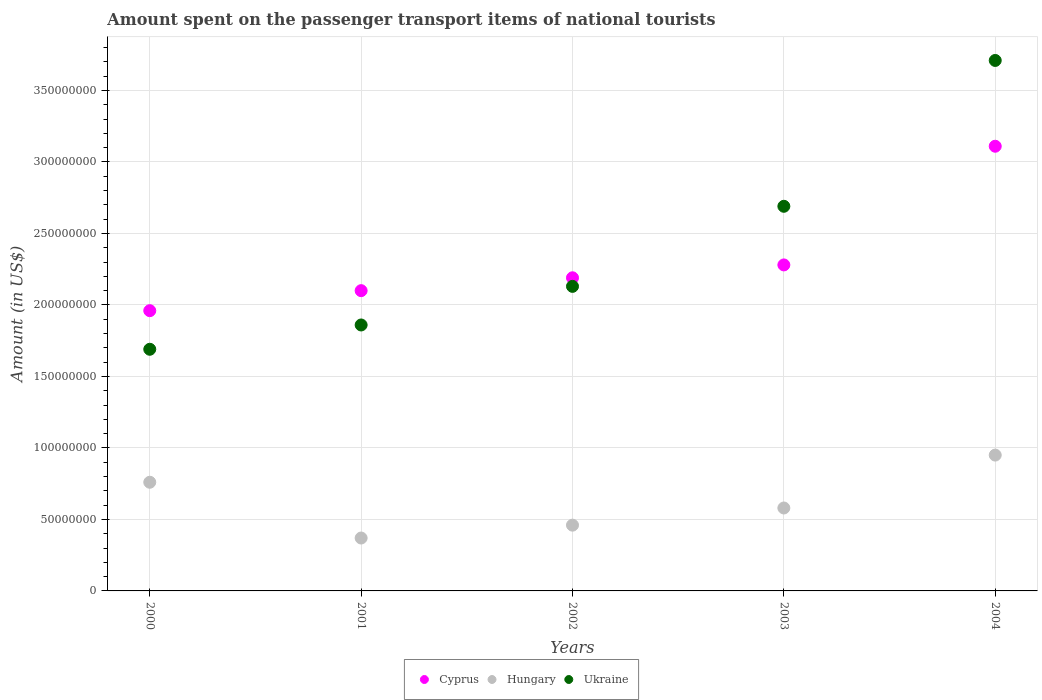How many different coloured dotlines are there?
Provide a succinct answer. 3. What is the amount spent on the passenger transport items of national tourists in Ukraine in 2001?
Your response must be concise. 1.86e+08. Across all years, what is the maximum amount spent on the passenger transport items of national tourists in Cyprus?
Make the answer very short. 3.11e+08. Across all years, what is the minimum amount spent on the passenger transport items of national tourists in Ukraine?
Your answer should be compact. 1.69e+08. What is the total amount spent on the passenger transport items of national tourists in Ukraine in the graph?
Give a very brief answer. 1.21e+09. What is the difference between the amount spent on the passenger transport items of national tourists in Ukraine in 2001 and that in 2004?
Provide a succinct answer. -1.85e+08. What is the difference between the amount spent on the passenger transport items of national tourists in Cyprus in 2002 and the amount spent on the passenger transport items of national tourists in Ukraine in 2000?
Provide a short and direct response. 5.00e+07. What is the average amount spent on the passenger transport items of national tourists in Hungary per year?
Provide a short and direct response. 6.24e+07. In the year 2002, what is the difference between the amount spent on the passenger transport items of national tourists in Hungary and amount spent on the passenger transport items of national tourists in Ukraine?
Offer a very short reply. -1.67e+08. In how many years, is the amount spent on the passenger transport items of national tourists in Ukraine greater than 270000000 US$?
Your response must be concise. 1. What is the ratio of the amount spent on the passenger transport items of national tourists in Ukraine in 2002 to that in 2003?
Keep it short and to the point. 0.79. Is the amount spent on the passenger transport items of national tourists in Cyprus in 2001 less than that in 2004?
Offer a terse response. Yes. Is the difference between the amount spent on the passenger transport items of national tourists in Hungary in 2000 and 2003 greater than the difference between the amount spent on the passenger transport items of national tourists in Ukraine in 2000 and 2003?
Make the answer very short. Yes. What is the difference between the highest and the second highest amount spent on the passenger transport items of national tourists in Hungary?
Provide a succinct answer. 1.90e+07. What is the difference between the highest and the lowest amount spent on the passenger transport items of national tourists in Ukraine?
Make the answer very short. 2.02e+08. In how many years, is the amount spent on the passenger transport items of national tourists in Cyprus greater than the average amount spent on the passenger transport items of national tourists in Cyprus taken over all years?
Make the answer very short. 1. Does the amount spent on the passenger transport items of national tourists in Ukraine monotonically increase over the years?
Ensure brevity in your answer.  Yes. Is the amount spent on the passenger transport items of national tourists in Ukraine strictly greater than the amount spent on the passenger transport items of national tourists in Cyprus over the years?
Ensure brevity in your answer.  No. Is the amount spent on the passenger transport items of national tourists in Hungary strictly less than the amount spent on the passenger transport items of national tourists in Cyprus over the years?
Your response must be concise. Yes. Are the values on the major ticks of Y-axis written in scientific E-notation?
Offer a terse response. No. Where does the legend appear in the graph?
Give a very brief answer. Bottom center. What is the title of the graph?
Give a very brief answer. Amount spent on the passenger transport items of national tourists. What is the label or title of the X-axis?
Keep it short and to the point. Years. What is the Amount (in US$) in Cyprus in 2000?
Give a very brief answer. 1.96e+08. What is the Amount (in US$) of Hungary in 2000?
Your answer should be very brief. 7.60e+07. What is the Amount (in US$) in Ukraine in 2000?
Your answer should be compact. 1.69e+08. What is the Amount (in US$) of Cyprus in 2001?
Your response must be concise. 2.10e+08. What is the Amount (in US$) of Hungary in 2001?
Make the answer very short. 3.70e+07. What is the Amount (in US$) of Ukraine in 2001?
Make the answer very short. 1.86e+08. What is the Amount (in US$) of Cyprus in 2002?
Offer a very short reply. 2.19e+08. What is the Amount (in US$) of Hungary in 2002?
Ensure brevity in your answer.  4.60e+07. What is the Amount (in US$) of Ukraine in 2002?
Offer a terse response. 2.13e+08. What is the Amount (in US$) in Cyprus in 2003?
Keep it short and to the point. 2.28e+08. What is the Amount (in US$) of Hungary in 2003?
Give a very brief answer. 5.80e+07. What is the Amount (in US$) of Ukraine in 2003?
Make the answer very short. 2.69e+08. What is the Amount (in US$) of Cyprus in 2004?
Your response must be concise. 3.11e+08. What is the Amount (in US$) of Hungary in 2004?
Offer a very short reply. 9.50e+07. What is the Amount (in US$) of Ukraine in 2004?
Your answer should be very brief. 3.71e+08. Across all years, what is the maximum Amount (in US$) of Cyprus?
Offer a very short reply. 3.11e+08. Across all years, what is the maximum Amount (in US$) of Hungary?
Keep it short and to the point. 9.50e+07. Across all years, what is the maximum Amount (in US$) of Ukraine?
Give a very brief answer. 3.71e+08. Across all years, what is the minimum Amount (in US$) in Cyprus?
Provide a succinct answer. 1.96e+08. Across all years, what is the minimum Amount (in US$) in Hungary?
Offer a terse response. 3.70e+07. Across all years, what is the minimum Amount (in US$) of Ukraine?
Keep it short and to the point. 1.69e+08. What is the total Amount (in US$) in Cyprus in the graph?
Your answer should be compact. 1.16e+09. What is the total Amount (in US$) in Hungary in the graph?
Provide a succinct answer. 3.12e+08. What is the total Amount (in US$) of Ukraine in the graph?
Ensure brevity in your answer.  1.21e+09. What is the difference between the Amount (in US$) in Cyprus in 2000 and that in 2001?
Keep it short and to the point. -1.40e+07. What is the difference between the Amount (in US$) in Hungary in 2000 and that in 2001?
Make the answer very short. 3.90e+07. What is the difference between the Amount (in US$) of Ukraine in 2000 and that in 2001?
Your response must be concise. -1.70e+07. What is the difference between the Amount (in US$) in Cyprus in 2000 and that in 2002?
Provide a succinct answer. -2.30e+07. What is the difference between the Amount (in US$) in Hungary in 2000 and that in 2002?
Your response must be concise. 3.00e+07. What is the difference between the Amount (in US$) of Ukraine in 2000 and that in 2002?
Give a very brief answer. -4.40e+07. What is the difference between the Amount (in US$) of Cyprus in 2000 and that in 2003?
Your answer should be very brief. -3.20e+07. What is the difference between the Amount (in US$) of Hungary in 2000 and that in 2003?
Make the answer very short. 1.80e+07. What is the difference between the Amount (in US$) in Ukraine in 2000 and that in 2003?
Give a very brief answer. -1.00e+08. What is the difference between the Amount (in US$) in Cyprus in 2000 and that in 2004?
Your answer should be compact. -1.15e+08. What is the difference between the Amount (in US$) in Hungary in 2000 and that in 2004?
Offer a terse response. -1.90e+07. What is the difference between the Amount (in US$) in Ukraine in 2000 and that in 2004?
Make the answer very short. -2.02e+08. What is the difference between the Amount (in US$) of Cyprus in 2001 and that in 2002?
Offer a terse response. -9.00e+06. What is the difference between the Amount (in US$) in Hungary in 2001 and that in 2002?
Offer a very short reply. -9.00e+06. What is the difference between the Amount (in US$) of Ukraine in 2001 and that in 2002?
Your response must be concise. -2.70e+07. What is the difference between the Amount (in US$) of Cyprus in 2001 and that in 2003?
Provide a succinct answer. -1.80e+07. What is the difference between the Amount (in US$) of Hungary in 2001 and that in 2003?
Make the answer very short. -2.10e+07. What is the difference between the Amount (in US$) of Ukraine in 2001 and that in 2003?
Your answer should be compact. -8.30e+07. What is the difference between the Amount (in US$) in Cyprus in 2001 and that in 2004?
Your answer should be compact. -1.01e+08. What is the difference between the Amount (in US$) of Hungary in 2001 and that in 2004?
Give a very brief answer. -5.80e+07. What is the difference between the Amount (in US$) in Ukraine in 2001 and that in 2004?
Provide a short and direct response. -1.85e+08. What is the difference between the Amount (in US$) in Cyprus in 2002 and that in 2003?
Make the answer very short. -9.00e+06. What is the difference between the Amount (in US$) of Hungary in 2002 and that in 2003?
Provide a succinct answer. -1.20e+07. What is the difference between the Amount (in US$) of Ukraine in 2002 and that in 2003?
Your answer should be compact. -5.60e+07. What is the difference between the Amount (in US$) of Cyprus in 2002 and that in 2004?
Your answer should be compact. -9.20e+07. What is the difference between the Amount (in US$) in Hungary in 2002 and that in 2004?
Provide a succinct answer. -4.90e+07. What is the difference between the Amount (in US$) in Ukraine in 2002 and that in 2004?
Your answer should be very brief. -1.58e+08. What is the difference between the Amount (in US$) of Cyprus in 2003 and that in 2004?
Your answer should be compact. -8.30e+07. What is the difference between the Amount (in US$) of Hungary in 2003 and that in 2004?
Offer a terse response. -3.70e+07. What is the difference between the Amount (in US$) in Ukraine in 2003 and that in 2004?
Your answer should be compact. -1.02e+08. What is the difference between the Amount (in US$) in Cyprus in 2000 and the Amount (in US$) in Hungary in 2001?
Your response must be concise. 1.59e+08. What is the difference between the Amount (in US$) of Hungary in 2000 and the Amount (in US$) of Ukraine in 2001?
Make the answer very short. -1.10e+08. What is the difference between the Amount (in US$) in Cyprus in 2000 and the Amount (in US$) in Hungary in 2002?
Your answer should be very brief. 1.50e+08. What is the difference between the Amount (in US$) of Cyprus in 2000 and the Amount (in US$) of Ukraine in 2002?
Make the answer very short. -1.70e+07. What is the difference between the Amount (in US$) in Hungary in 2000 and the Amount (in US$) in Ukraine in 2002?
Offer a very short reply. -1.37e+08. What is the difference between the Amount (in US$) of Cyprus in 2000 and the Amount (in US$) of Hungary in 2003?
Keep it short and to the point. 1.38e+08. What is the difference between the Amount (in US$) in Cyprus in 2000 and the Amount (in US$) in Ukraine in 2003?
Give a very brief answer. -7.30e+07. What is the difference between the Amount (in US$) of Hungary in 2000 and the Amount (in US$) of Ukraine in 2003?
Give a very brief answer. -1.93e+08. What is the difference between the Amount (in US$) in Cyprus in 2000 and the Amount (in US$) in Hungary in 2004?
Ensure brevity in your answer.  1.01e+08. What is the difference between the Amount (in US$) in Cyprus in 2000 and the Amount (in US$) in Ukraine in 2004?
Make the answer very short. -1.75e+08. What is the difference between the Amount (in US$) in Hungary in 2000 and the Amount (in US$) in Ukraine in 2004?
Provide a short and direct response. -2.95e+08. What is the difference between the Amount (in US$) of Cyprus in 2001 and the Amount (in US$) of Hungary in 2002?
Offer a very short reply. 1.64e+08. What is the difference between the Amount (in US$) in Cyprus in 2001 and the Amount (in US$) in Ukraine in 2002?
Provide a succinct answer. -3.00e+06. What is the difference between the Amount (in US$) of Hungary in 2001 and the Amount (in US$) of Ukraine in 2002?
Your answer should be very brief. -1.76e+08. What is the difference between the Amount (in US$) of Cyprus in 2001 and the Amount (in US$) of Hungary in 2003?
Ensure brevity in your answer.  1.52e+08. What is the difference between the Amount (in US$) of Cyprus in 2001 and the Amount (in US$) of Ukraine in 2003?
Provide a short and direct response. -5.90e+07. What is the difference between the Amount (in US$) in Hungary in 2001 and the Amount (in US$) in Ukraine in 2003?
Offer a very short reply. -2.32e+08. What is the difference between the Amount (in US$) in Cyprus in 2001 and the Amount (in US$) in Hungary in 2004?
Your answer should be very brief. 1.15e+08. What is the difference between the Amount (in US$) in Cyprus in 2001 and the Amount (in US$) in Ukraine in 2004?
Keep it short and to the point. -1.61e+08. What is the difference between the Amount (in US$) in Hungary in 2001 and the Amount (in US$) in Ukraine in 2004?
Ensure brevity in your answer.  -3.34e+08. What is the difference between the Amount (in US$) of Cyprus in 2002 and the Amount (in US$) of Hungary in 2003?
Your answer should be very brief. 1.61e+08. What is the difference between the Amount (in US$) of Cyprus in 2002 and the Amount (in US$) of Ukraine in 2003?
Your response must be concise. -5.00e+07. What is the difference between the Amount (in US$) in Hungary in 2002 and the Amount (in US$) in Ukraine in 2003?
Provide a succinct answer. -2.23e+08. What is the difference between the Amount (in US$) in Cyprus in 2002 and the Amount (in US$) in Hungary in 2004?
Ensure brevity in your answer.  1.24e+08. What is the difference between the Amount (in US$) in Cyprus in 2002 and the Amount (in US$) in Ukraine in 2004?
Your answer should be very brief. -1.52e+08. What is the difference between the Amount (in US$) of Hungary in 2002 and the Amount (in US$) of Ukraine in 2004?
Your answer should be compact. -3.25e+08. What is the difference between the Amount (in US$) of Cyprus in 2003 and the Amount (in US$) of Hungary in 2004?
Provide a short and direct response. 1.33e+08. What is the difference between the Amount (in US$) of Cyprus in 2003 and the Amount (in US$) of Ukraine in 2004?
Provide a succinct answer. -1.43e+08. What is the difference between the Amount (in US$) in Hungary in 2003 and the Amount (in US$) in Ukraine in 2004?
Your response must be concise. -3.13e+08. What is the average Amount (in US$) in Cyprus per year?
Keep it short and to the point. 2.33e+08. What is the average Amount (in US$) of Hungary per year?
Keep it short and to the point. 6.24e+07. What is the average Amount (in US$) in Ukraine per year?
Provide a succinct answer. 2.42e+08. In the year 2000, what is the difference between the Amount (in US$) of Cyprus and Amount (in US$) of Hungary?
Your response must be concise. 1.20e+08. In the year 2000, what is the difference between the Amount (in US$) of Cyprus and Amount (in US$) of Ukraine?
Provide a succinct answer. 2.70e+07. In the year 2000, what is the difference between the Amount (in US$) in Hungary and Amount (in US$) in Ukraine?
Offer a terse response. -9.30e+07. In the year 2001, what is the difference between the Amount (in US$) of Cyprus and Amount (in US$) of Hungary?
Provide a succinct answer. 1.73e+08. In the year 2001, what is the difference between the Amount (in US$) of Cyprus and Amount (in US$) of Ukraine?
Ensure brevity in your answer.  2.40e+07. In the year 2001, what is the difference between the Amount (in US$) in Hungary and Amount (in US$) in Ukraine?
Your answer should be compact. -1.49e+08. In the year 2002, what is the difference between the Amount (in US$) in Cyprus and Amount (in US$) in Hungary?
Provide a succinct answer. 1.73e+08. In the year 2002, what is the difference between the Amount (in US$) of Hungary and Amount (in US$) of Ukraine?
Provide a short and direct response. -1.67e+08. In the year 2003, what is the difference between the Amount (in US$) of Cyprus and Amount (in US$) of Hungary?
Offer a terse response. 1.70e+08. In the year 2003, what is the difference between the Amount (in US$) of Cyprus and Amount (in US$) of Ukraine?
Offer a very short reply. -4.10e+07. In the year 2003, what is the difference between the Amount (in US$) in Hungary and Amount (in US$) in Ukraine?
Your answer should be very brief. -2.11e+08. In the year 2004, what is the difference between the Amount (in US$) in Cyprus and Amount (in US$) in Hungary?
Make the answer very short. 2.16e+08. In the year 2004, what is the difference between the Amount (in US$) in Cyprus and Amount (in US$) in Ukraine?
Offer a very short reply. -6.00e+07. In the year 2004, what is the difference between the Amount (in US$) of Hungary and Amount (in US$) of Ukraine?
Your answer should be compact. -2.76e+08. What is the ratio of the Amount (in US$) of Hungary in 2000 to that in 2001?
Offer a very short reply. 2.05. What is the ratio of the Amount (in US$) in Ukraine in 2000 to that in 2001?
Provide a short and direct response. 0.91. What is the ratio of the Amount (in US$) in Cyprus in 2000 to that in 2002?
Your answer should be compact. 0.9. What is the ratio of the Amount (in US$) of Hungary in 2000 to that in 2002?
Make the answer very short. 1.65. What is the ratio of the Amount (in US$) of Ukraine in 2000 to that in 2002?
Offer a terse response. 0.79. What is the ratio of the Amount (in US$) of Cyprus in 2000 to that in 2003?
Make the answer very short. 0.86. What is the ratio of the Amount (in US$) in Hungary in 2000 to that in 2003?
Provide a short and direct response. 1.31. What is the ratio of the Amount (in US$) in Ukraine in 2000 to that in 2003?
Offer a very short reply. 0.63. What is the ratio of the Amount (in US$) of Cyprus in 2000 to that in 2004?
Offer a very short reply. 0.63. What is the ratio of the Amount (in US$) in Ukraine in 2000 to that in 2004?
Keep it short and to the point. 0.46. What is the ratio of the Amount (in US$) of Cyprus in 2001 to that in 2002?
Ensure brevity in your answer.  0.96. What is the ratio of the Amount (in US$) of Hungary in 2001 to that in 2002?
Your answer should be compact. 0.8. What is the ratio of the Amount (in US$) of Ukraine in 2001 to that in 2002?
Offer a very short reply. 0.87. What is the ratio of the Amount (in US$) of Cyprus in 2001 to that in 2003?
Ensure brevity in your answer.  0.92. What is the ratio of the Amount (in US$) of Hungary in 2001 to that in 2003?
Provide a short and direct response. 0.64. What is the ratio of the Amount (in US$) in Ukraine in 2001 to that in 2003?
Offer a very short reply. 0.69. What is the ratio of the Amount (in US$) of Cyprus in 2001 to that in 2004?
Your answer should be compact. 0.68. What is the ratio of the Amount (in US$) of Hungary in 2001 to that in 2004?
Offer a very short reply. 0.39. What is the ratio of the Amount (in US$) in Ukraine in 2001 to that in 2004?
Make the answer very short. 0.5. What is the ratio of the Amount (in US$) in Cyprus in 2002 to that in 2003?
Make the answer very short. 0.96. What is the ratio of the Amount (in US$) in Hungary in 2002 to that in 2003?
Your answer should be very brief. 0.79. What is the ratio of the Amount (in US$) of Ukraine in 2002 to that in 2003?
Your answer should be compact. 0.79. What is the ratio of the Amount (in US$) in Cyprus in 2002 to that in 2004?
Provide a short and direct response. 0.7. What is the ratio of the Amount (in US$) in Hungary in 2002 to that in 2004?
Give a very brief answer. 0.48. What is the ratio of the Amount (in US$) in Ukraine in 2002 to that in 2004?
Keep it short and to the point. 0.57. What is the ratio of the Amount (in US$) of Cyprus in 2003 to that in 2004?
Your answer should be compact. 0.73. What is the ratio of the Amount (in US$) of Hungary in 2003 to that in 2004?
Your response must be concise. 0.61. What is the ratio of the Amount (in US$) of Ukraine in 2003 to that in 2004?
Ensure brevity in your answer.  0.73. What is the difference between the highest and the second highest Amount (in US$) of Cyprus?
Offer a terse response. 8.30e+07. What is the difference between the highest and the second highest Amount (in US$) in Hungary?
Make the answer very short. 1.90e+07. What is the difference between the highest and the second highest Amount (in US$) in Ukraine?
Your answer should be compact. 1.02e+08. What is the difference between the highest and the lowest Amount (in US$) of Cyprus?
Your answer should be compact. 1.15e+08. What is the difference between the highest and the lowest Amount (in US$) of Hungary?
Give a very brief answer. 5.80e+07. What is the difference between the highest and the lowest Amount (in US$) of Ukraine?
Ensure brevity in your answer.  2.02e+08. 